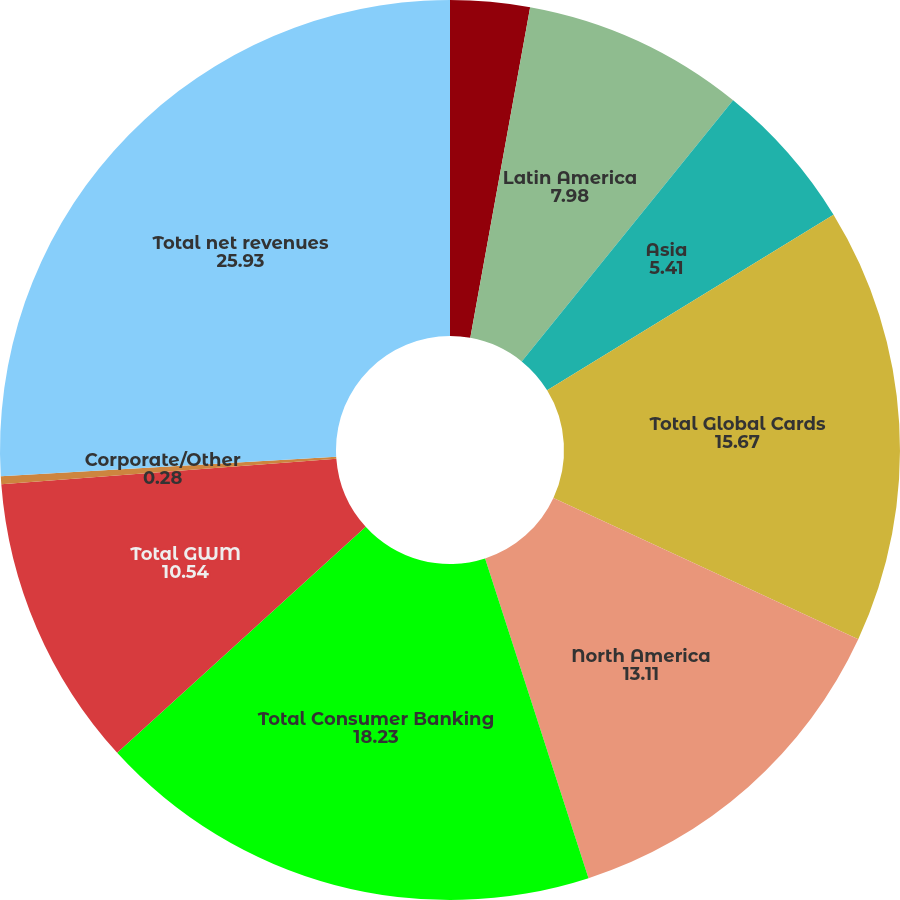Convert chart to OTSL. <chart><loc_0><loc_0><loc_500><loc_500><pie_chart><fcel>EMEA<fcel>Latin America<fcel>Asia<fcel>Total Global Cards<fcel>North America<fcel>Total Consumer Banking<fcel>Total GWM<fcel>Corporate/Other<fcel>Total net revenues<nl><fcel>2.85%<fcel>7.98%<fcel>5.41%<fcel>15.67%<fcel>13.11%<fcel>18.23%<fcel>10.54%<fcel>0.28%<fcel>25.93%<nl></chart> 